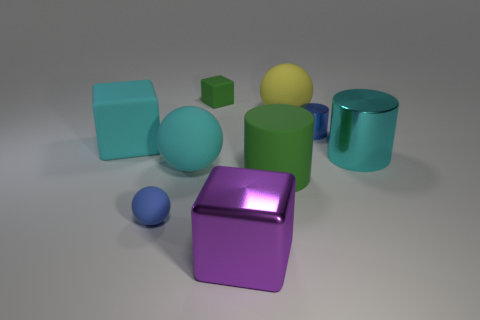Subtract all large cyan matte cubes. How many cubes are left? 2 Subtract 2 balls. How many balls are left? 1 Subtract all blocks. How many objects are left? 6 Subtract all large yellow metal balls. Subtract all large cyan spheres. How many objects are left? 8 Add 7 tiny green matte objects. How many tiny green matte objects are left? 8 Add 6 purple things. How many purple things exist? 7 Subtract 0 brown blocks. How many objects are left? 9 Subtract all purple blocks. Subtract all green spheres. How many blocks are left? 2 Subtract all cyan cylinders. How many yellow spheres are left? 1 